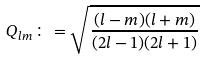Convert formula to latex. <formula><loc_0><loc_0><loc_500><loc_500>Q _ { l m } \colon = \sqrt { \frac { ( l - m ) ( l + m ) } { ( 2 l - 1 ) ( 2 l + 1 ) } }</formula> 